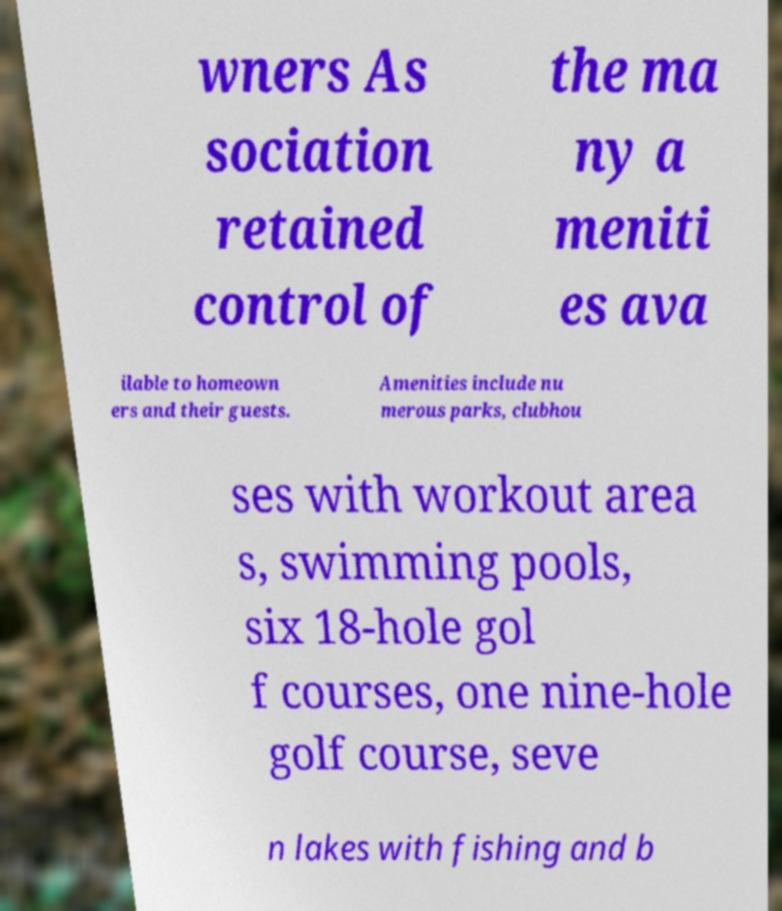Can you read and provide the text displayed in the image?This photo seems to have some interesting text. Can you extract and type it out for me? wners As sociation retained control of the ma ny a meniti es ava ilable to homeown ers and their guests. Amenities include nu merous parks, clubhou ses with workout area s, swimming pools, six 18-hole gol f courses, one nine-hole golf course, seve n lakes with fishing and b 